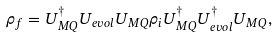Convert formula to latex. <formula><loc_0><loc_0><loc_500><loc_500>\rho _ { f } = U _ { M Q } ^ { \dag } U _ { e v o l } U _ { M Q } \rho _ { i } U _ { M Q } ^ { \dag } U _ { e v o l } ^ { \dag } U _ { M Q } ,</formula> 